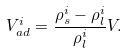<formula> <loc_0><loc_0><loc_500><loc_500>V _ { a d } ^ { i } = \frac { \rho _ { s } ^ { i } - \rho _ { l } ^ { i } } { \rho _ { l } ^ { i } } V .</formula> 